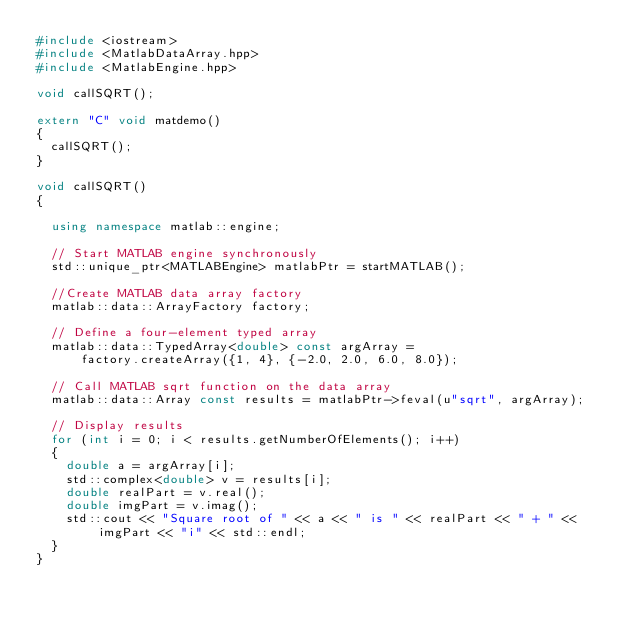Convert code to text. <code><loc_0><loc_0><loc_500><loc_500><_C++_>#include <iostream>
#include <MatlabDataArray.hpp>
#include <MatlabEngine.hpp>

void callSQRT();

extern "C" void matdemo()
{
  callSQRT();
}

void callSQRT()
{

  using namespace matlab::engine;

  // Start MATLAB engine synchronously
  std::unique_ptr<MATLABEngine> matlabPtr = startMATLAB();

  //Create MATLAB data array factory
  matlab::data::ArrayFactory factory;

  // Define a four-element typed array
  matlab::data::TypedArray<double> const argArray =
      factory.createArray({1, 4}, {-2.0, 2.0, 6.0, 8.0});

  // Call MATLAB sqrt function on the data array
  matlab::data::Array const results = matlabPtr->feval(u"sqrt", argArray);

  // Display results
  for (int i = 0; i < results.getNumberOfElements(); i++)
  {
    double a = argArray[i];
    std::complex<double> v = results[i];
    double realPart = v.real();
    double imgPart = v.imag();
    std::cout << "Square root of " << a << " is " << realPart << " + " << imgPart << "i" << std::endl;
  }
}</code> 